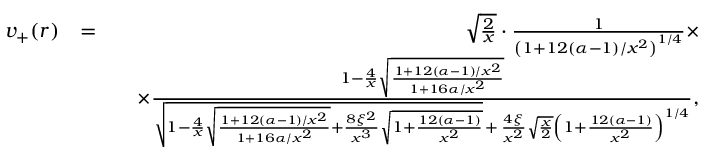Convert formula to latex. <formula><loc_0><loc_0><loc_500><loc_500>\begin{array} { r l r } { v _ { + } ( r ) } & { = } & { \sqrt { \frac { 2 } { x } } \cdot \frac { 1 } { \left ( 1 + 1 2 ( \alpha - 1 ) / x ^ { 2 } \right ) ^ { 1 / 4 } } \times } \\ & { \quad \times \frac { 1 - \frac { 4 } { x } \sqrt { \frac { 1 + 1 2 ( \alpha - 1 ) / x ^ { 2 } } { 1 + 1 6 \alpha / x ^ { 2 } } } } { \sqrt { 1 - \frac { 4 } { x } \sqrt { \frac { 1 + 1 2 ( \alpha - 1 ) / x ^ { 2 } } { 1 + 1 6 \alpha / x ^ { 2 } } } + \frac { 8 \xi ^ { 2 } } { x ^ { 3 } } \sqrt { 1 + \frac { 1 2 ( \alpha - 1 ) } { x ^ { 2 } } } } \, + \, \frac { 4 \xi } { x ^ { 2 } } \sqrt { \frac { x } { 2 } } \left ( 1 + \frac { 1 2 ( \alpha - 1 ) } { x ^ { 2 } } \right ) ^ { 1 / 4 } } , } \end{array}</formula> 